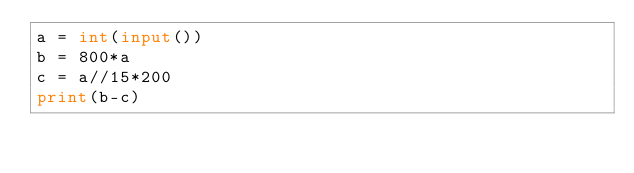<code> <loc_0><loc_0><loc_500><loc_500><_Python_>a = int(input())
b = 800*a
c = a//15*200
print(b-c)</code> 